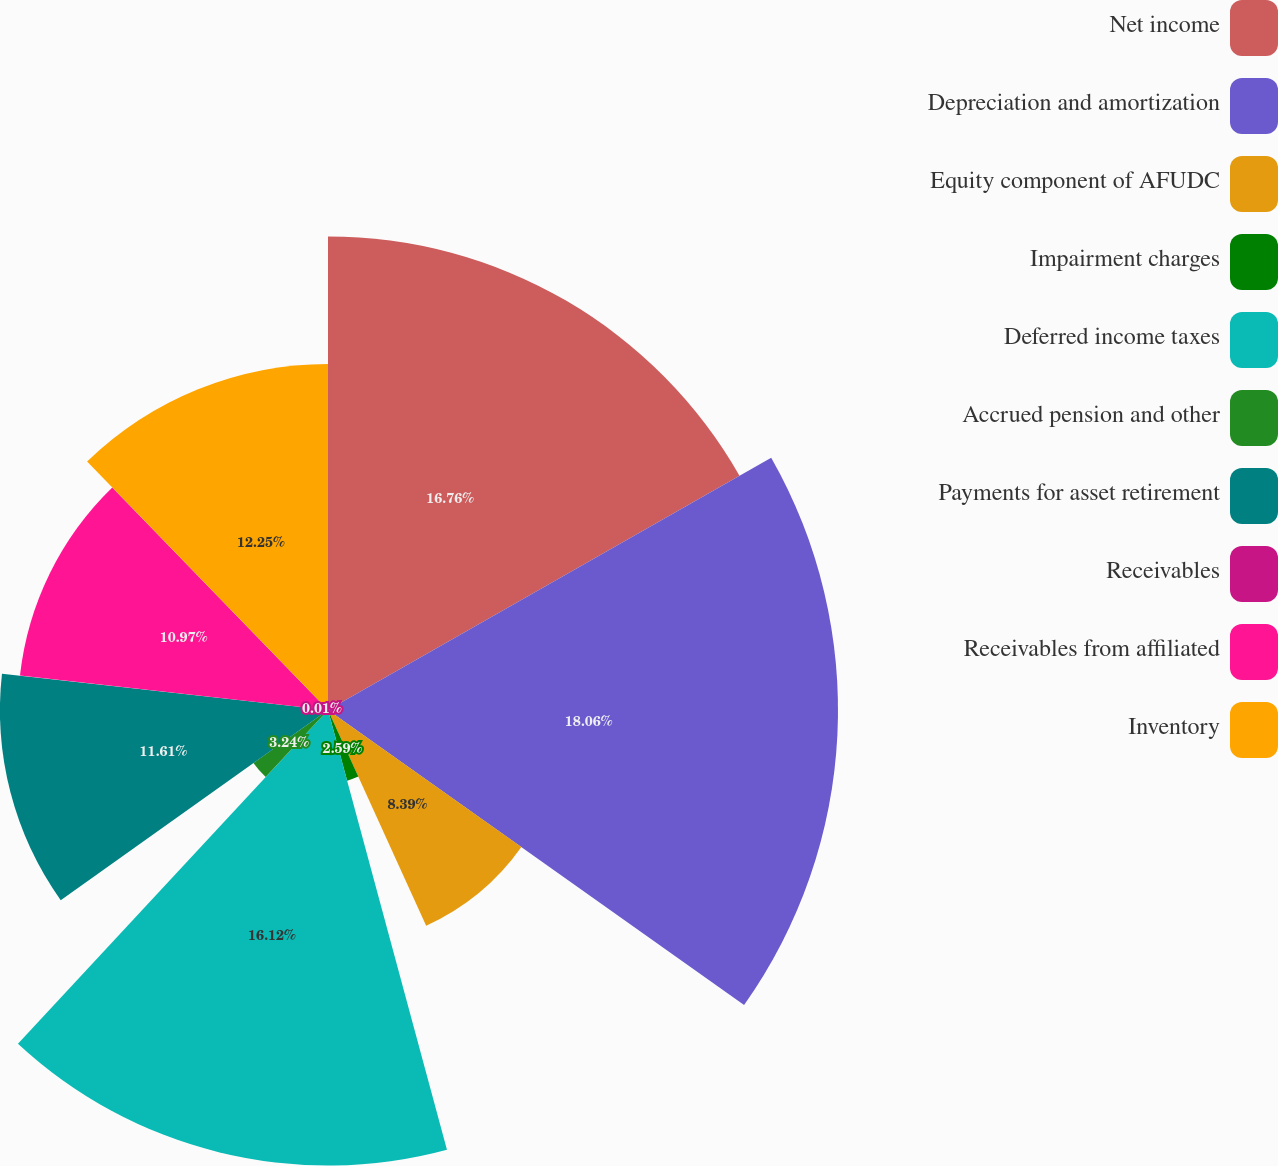Convert chart. <chart><loc_0><loc_0><loc_500><loc_500><pie_chart><fcel>Net income<fcel>Depreciation and amortization<fcel>Equity component of AFUDC<fcel>Impairment charges<fcel>Deferred income taxes<fcel>Accrued pension and other<fcel>Payments for asset retirement<fcel>Receivables<fcel>Receivables from affiliated<fcel>Inventory<nl><fcel>16.76%<fcel>18.05%<fcel>8.39%<fcel>2.59%<fcel>16.12%<fcel>3.24%<fcel>11.61%<fcel>0.01%<fcel>10.97%<fcel>12.25%<nl></chart> 